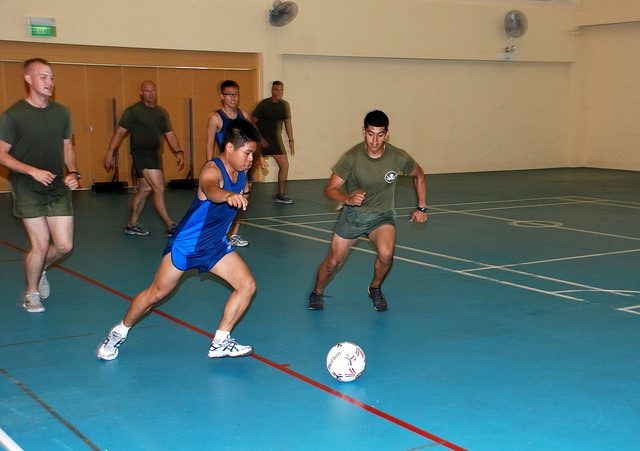Describe the objects in this image and their specific colors. I can see people in tan, navy, brown, and black tones, people in tan, black, brown, lightpink, and gray tones, people in tan, gray, black, and brown tones, people in tan, black, maroon, and brown tones, and people in tan, black, maroon, and brown tones in this image. 